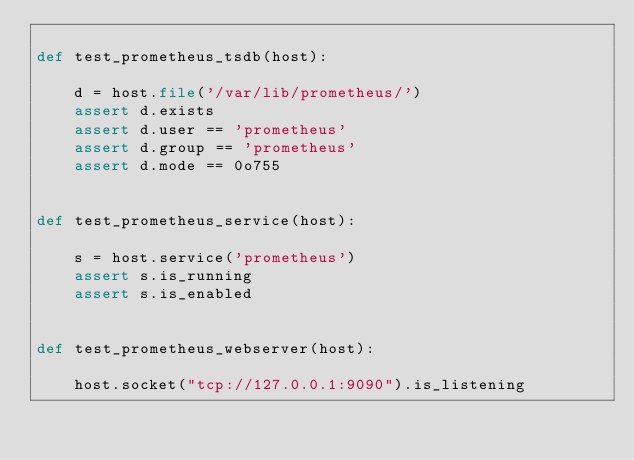<code> <loc_0><loc_0><loc_500><loc_500><_Python_>
def test_prometheus_tsdb(host):

    d = host.file('/var/lib/prometheus/')
    assert d.exists
    assert d.user == 'prometheus'
    assert d.group == 'prometheus'
    assert d.mode == 0o755


def test_prometheus_service(host):

    s = host.service('prometheus')
    assert s.is_running
    assert s.is_enabled


def test_prometheus_webserver(host):

    host.socket("tcp://127.0.0.1:9090").is_listening
</code> 